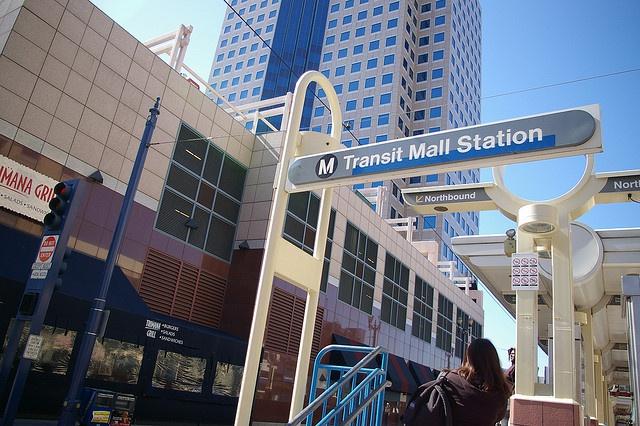Describe the objects in this image and their specific colors. I can see people in darkgray, black, gray, and maroon tones, backpack in darkgray, black, gray, and navy tones, traffic light in darkgray, black, navy, and maroon tones, and people in darkgray, black, gray, white, and maroon tones in this image. 